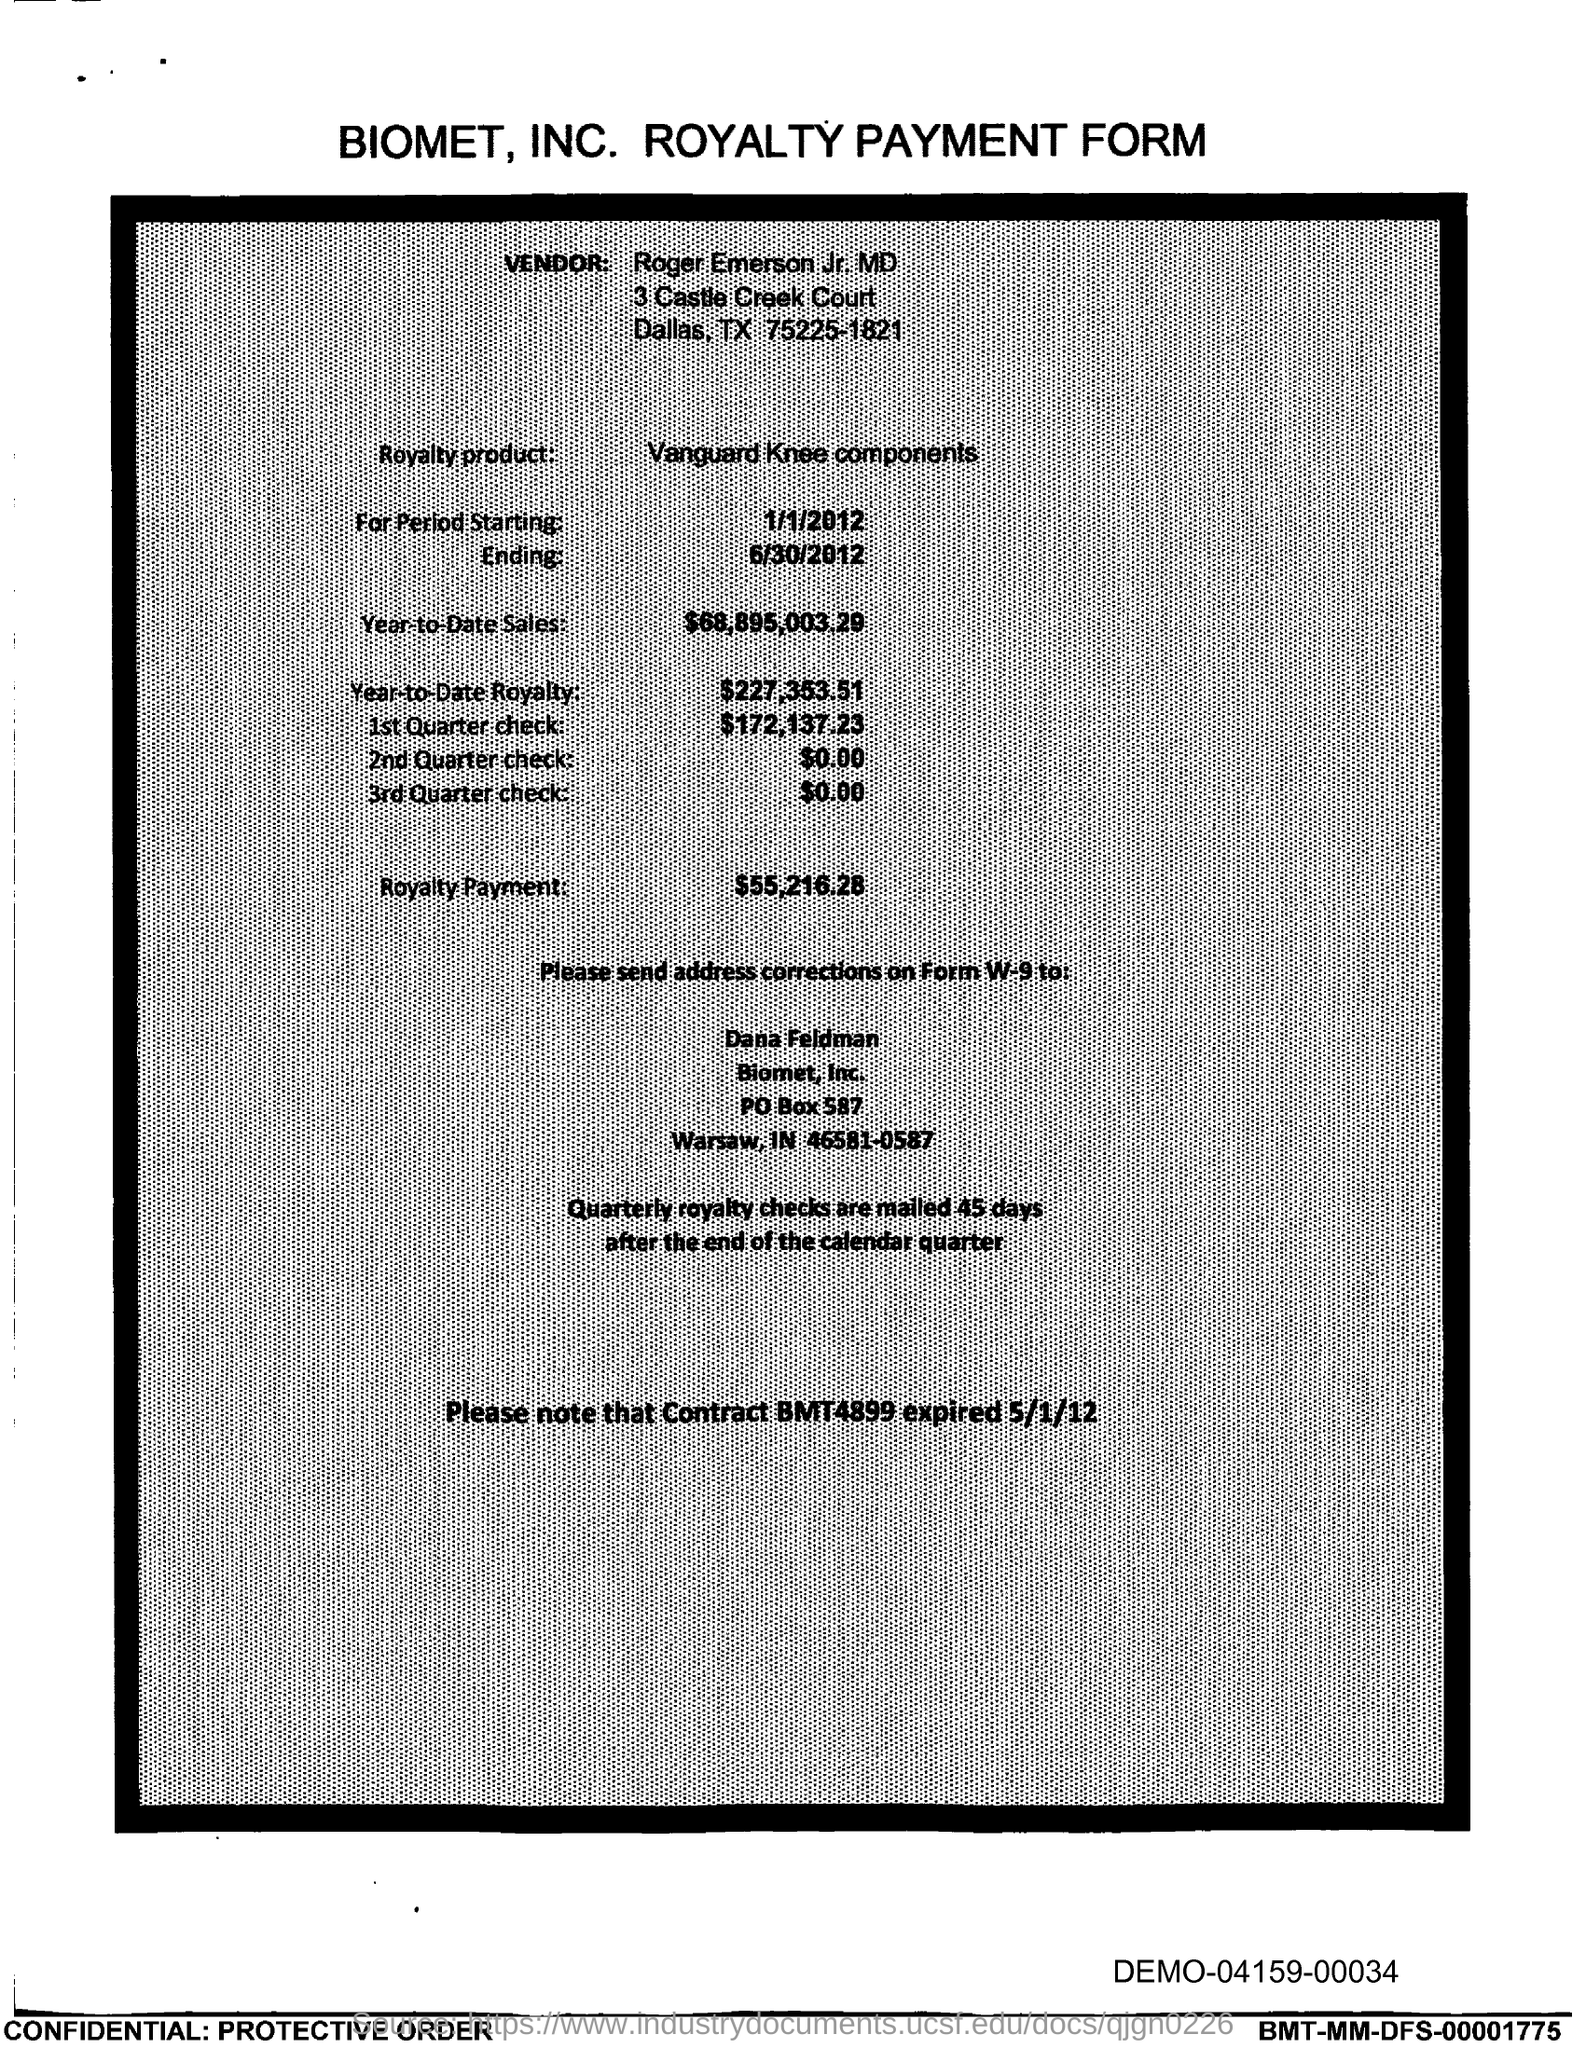Mention a couple of crucial points in this snapshot. The royalty payment is 55,216.28. The Contract BMT4899 expired on May 1st, 2012. The year-to-date royalty amount is $227,353.51. The period starting date given is 1/1/2012. Vanguard Knee components are the name of the Royalty product. 